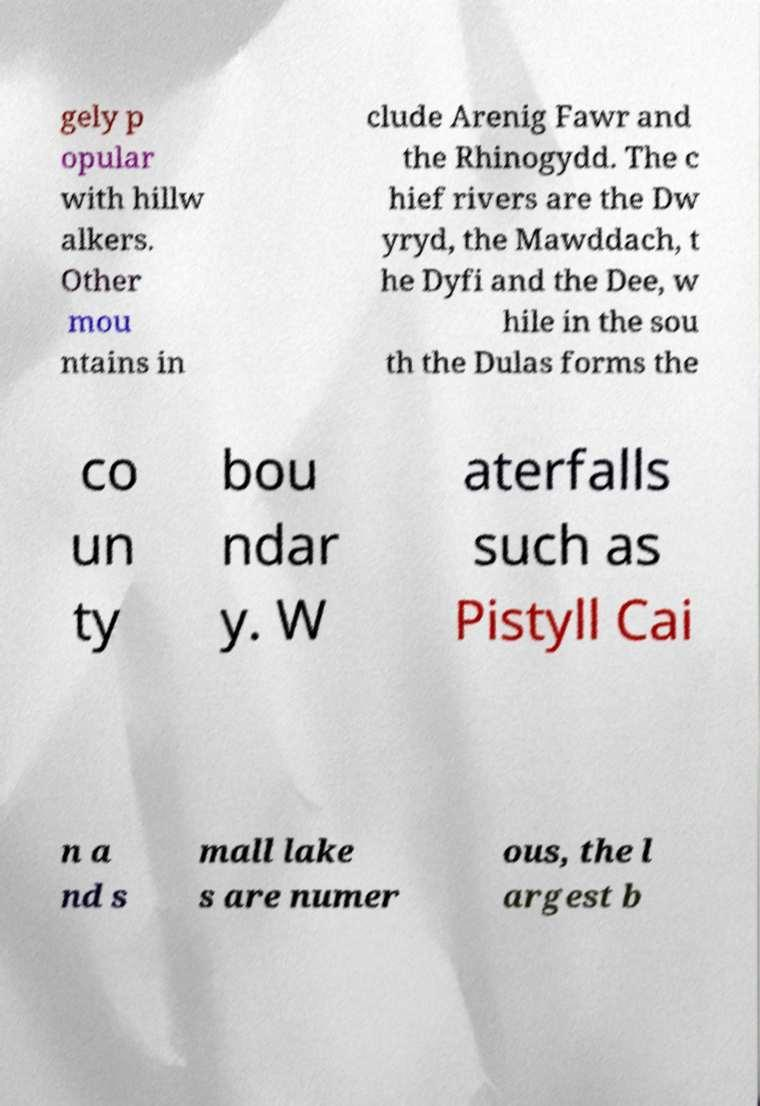What messages or text are displayed in this image? I need them in a readable, typed format. gely p opular with hillw alkers. Other mou ntains in clude Arenig Fawr and the Rhinogydd. The c hief rivers are the Dw yryd, the Mawddach, t he Dyfi and the Dee, w hile in the sou th the Dulas forms the co un ty bou ndar y. W aterfalls such as Pistyll Cai n a nd s mall lake s are numer ous, the l argest b 